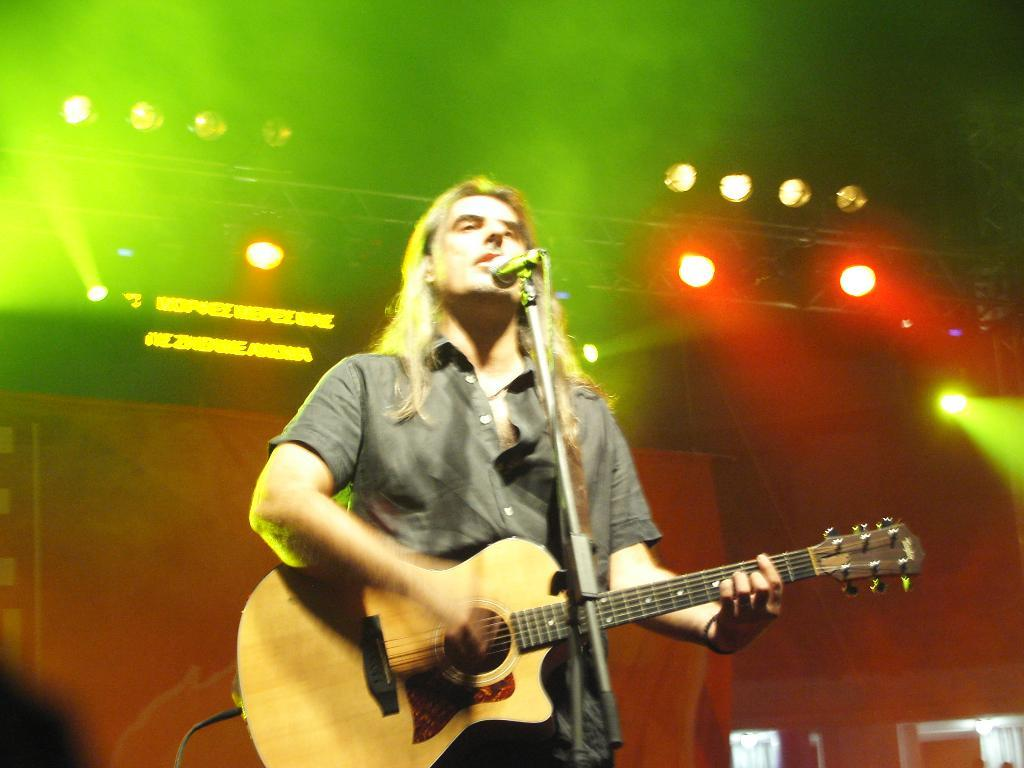What is the man in the image doing? The man is standing and playing a guitar. What object is present in the image that is typically used for amplifying sound? There is a microphone in the image. What type of support is visible in the image? There is a stand in the image. What can be seen in the background of the image? There is a light in the background of the image. How many dolls are sitting on the record in the image? There are no dolls or records present in the image. 